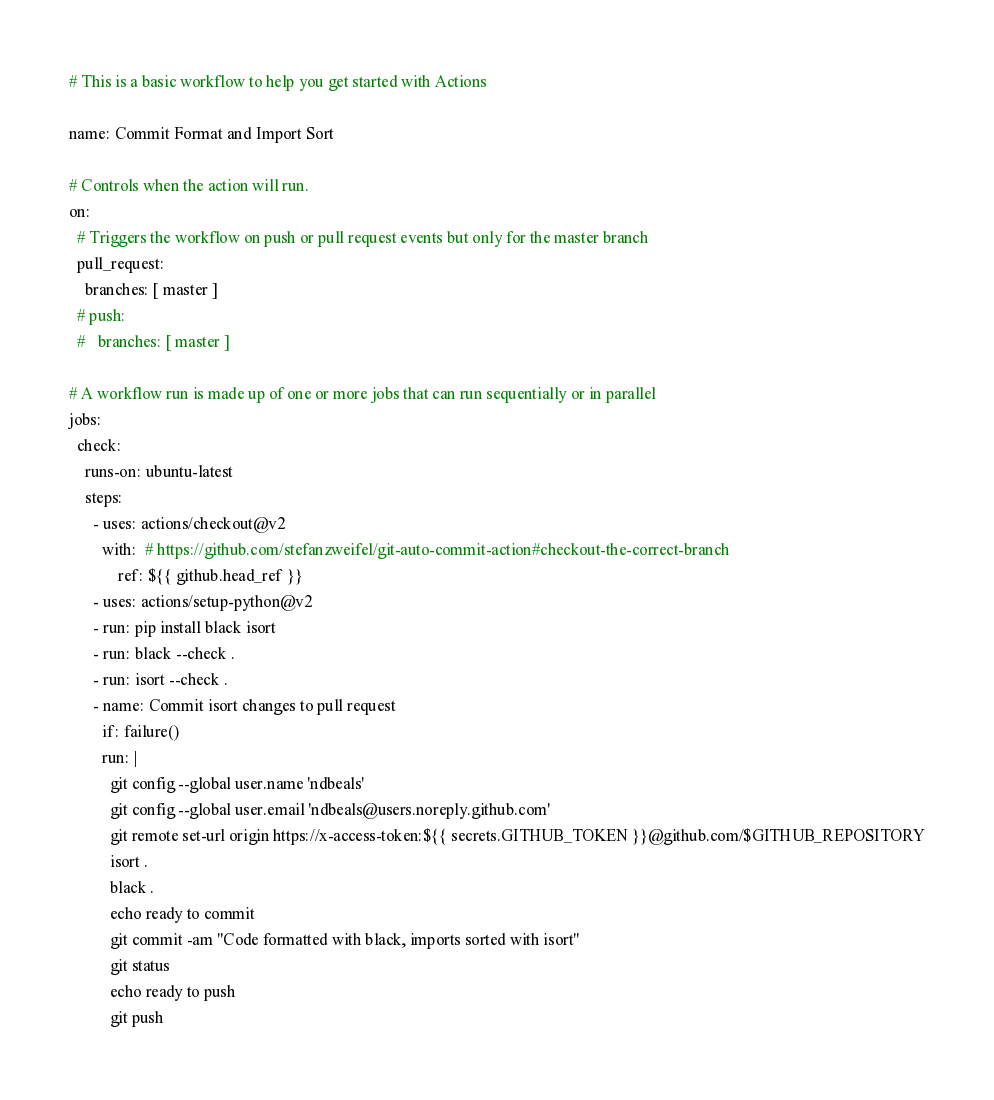Convert code to text. <code><loc_0><loc_0><loc_500><loc_500><_YAML_># This is a basic workflow to help you get started with Actions

name: Commit Format and Import Sort

# Controls when the action will run. 
on:
  # Triggers the workflow on push or pull request events but only for the master branch
  pull_request:
    branches: [ master ]
  # push:
  #   branches: [ master ]

# A workflow run is made up of one or more jobs that can run sequentially or in parallel
jobs:
  check:
    runs-on: ubuntu-latest
    steps:
      - uses: actions/checkout@v2
        with:  # https://github.com/stefanzweifel/git-auto-commit-action#checkout-the-correct-branch
            ref: ${{ github.head_ref }}
      - uses: actions/setup-python@v2
      - run: pip install black isort
      - run: black --check .
      - run: isort --check .
      - name: Commit isort changes to pull request
        if: failure()
        run: |
          git config --global user.name 'ndbeals'
          git config --global user.email 'ndbeals@users.noreply.github.com'          
          git remote set-url origin https://x-access-token:${{ secrets.GITHUB_TOKEN }}@github.com/$GITHUB_REPOSITORY
          isort .
          black .
          echo ready to commit
          git commit -am "Code formatted with black, imports sorted with isort"
          git status
          echo ready to push
          git push
</code> 